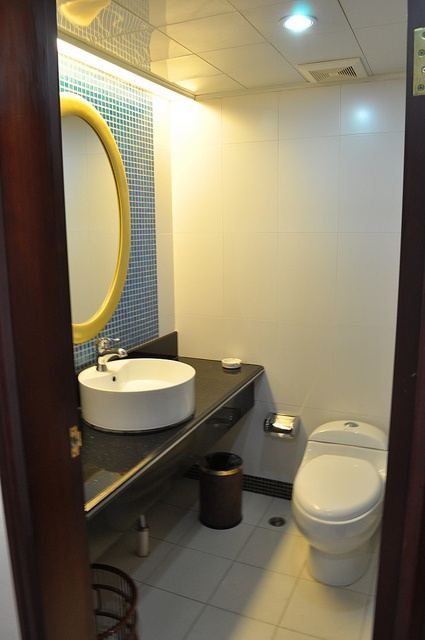Describe the objects in this image and their specific colors. I can see toilet in maroon, gray, and tan tones and sink in maroon, khaki, gray, and lightyellow tones in this image. 